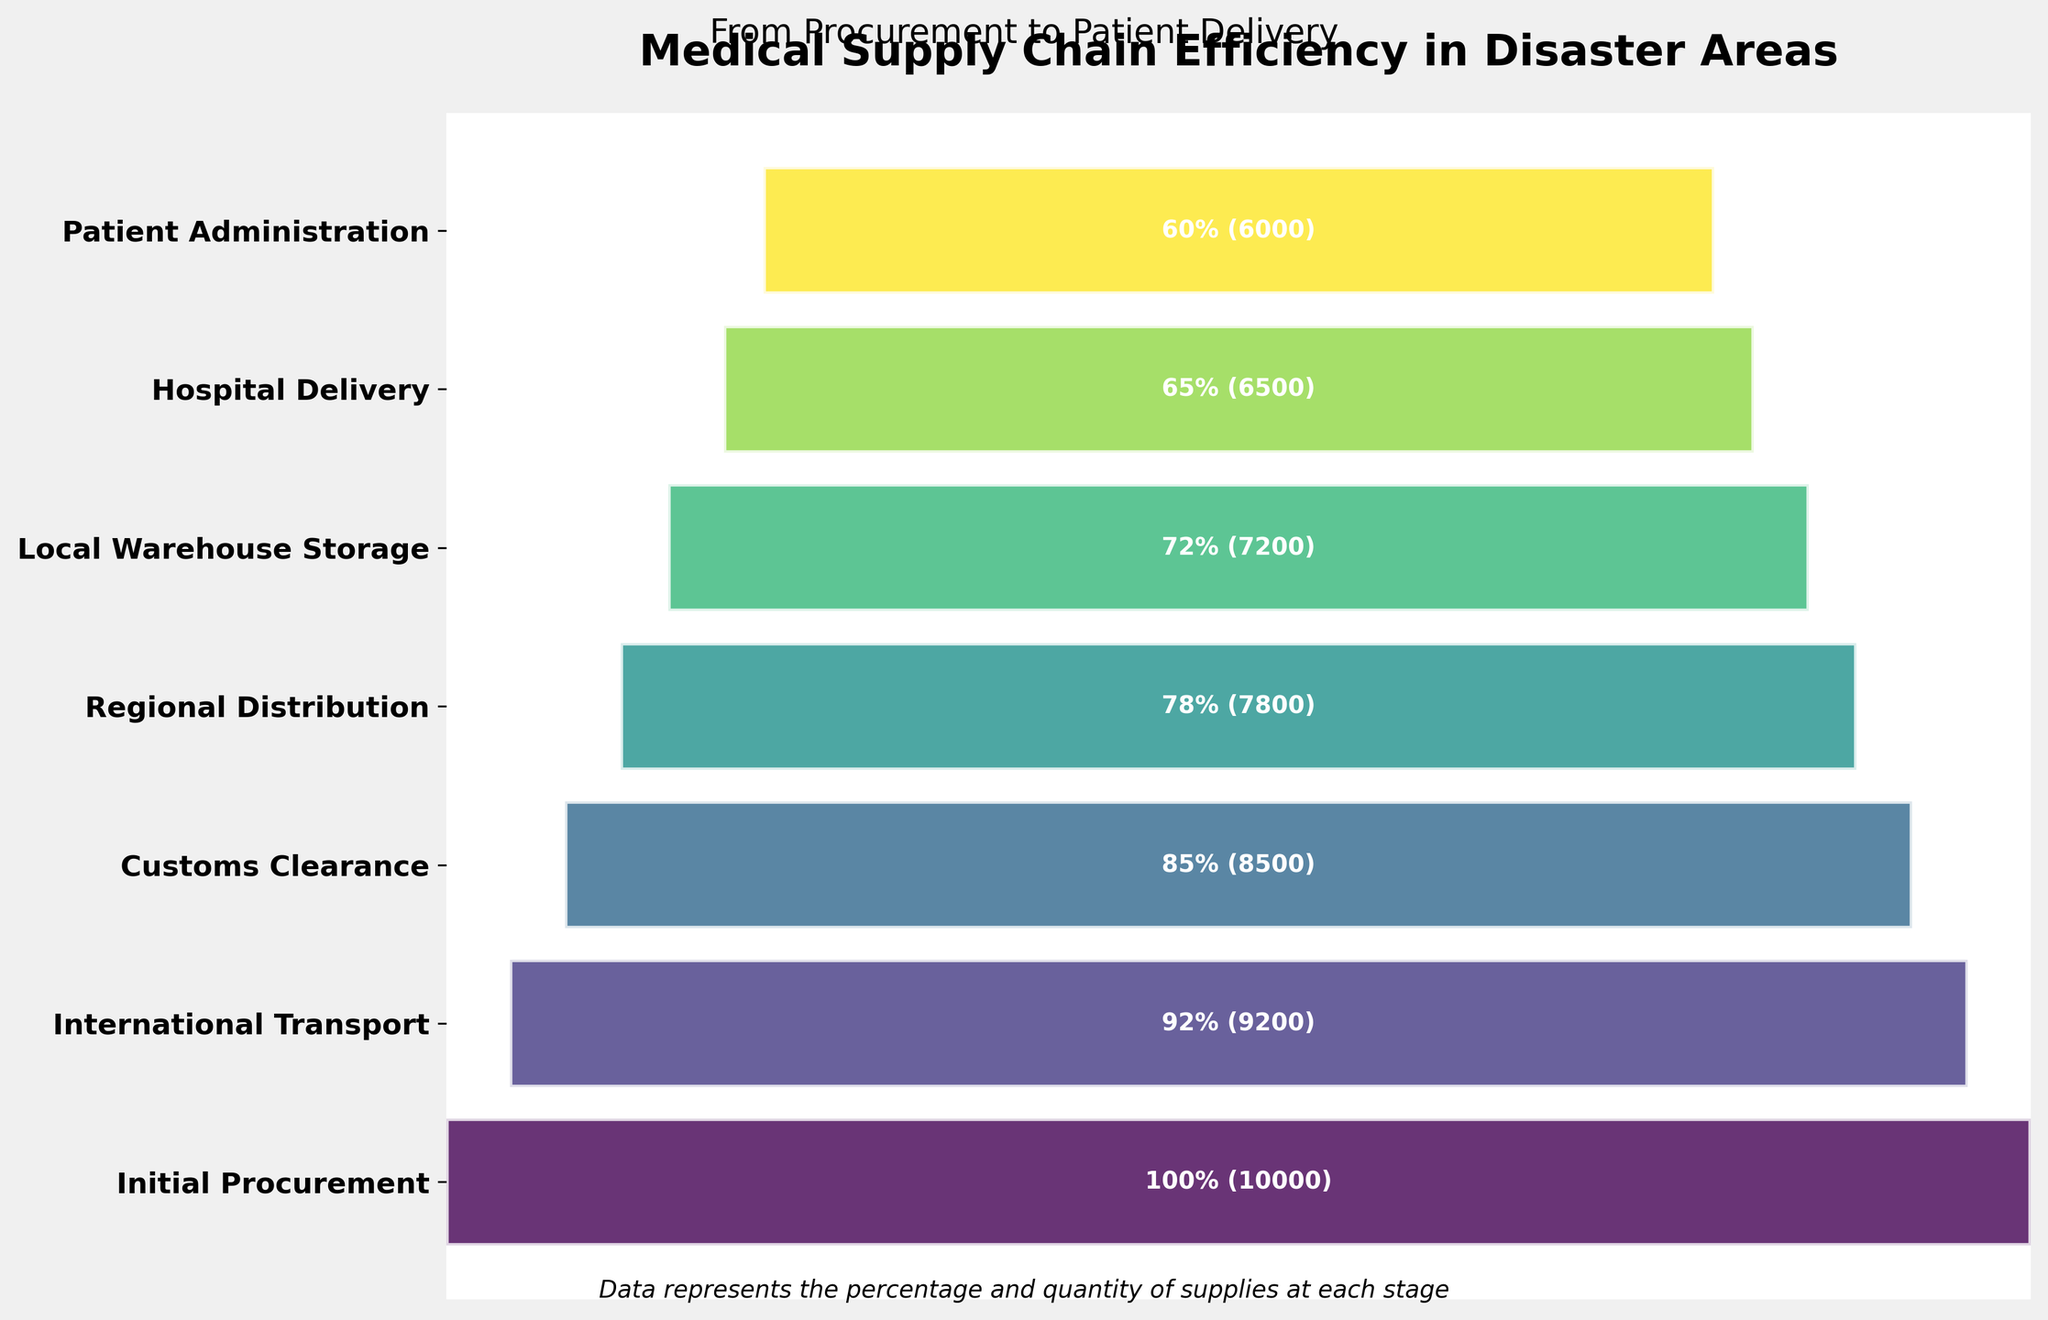What is the title of the plot? The title of the plot is the text located at the top of the figure which indicates the main topic. The title reads "Medical Supply Chain Efficiency in Disaster Areas."
Answer: Medical Supply Chain Efficiency in Disaster Areas What percentage of supplies remains after the International Transport stage? The stage labeled "International Transport" shows a percentage. By referring to this stage, we see that it shows 92%.
Answer: 92% How many supplies reach the patients? The last stage labeled "Patient Administration" shows both a percentage and the quantity. The quantity is inside the bar. There, it indicates 6000 supplies reach the patients.
Answer: 6000 What is the percentage difference between Initial Procurement and Hospital Delivery? The percentages for "Initial Procurement" and "Hospital Delivery" are 100% and 65%, respectively. To find the difference, subtract 65% from 100%, which is 35%.
Answer: 35% Which stage has the lowest percentage of supplies? By looking at all the stages and their respective percentages, the stage labeled "Patient Administration" has the lowest percentage which is 60%.
Answer: Patient Administration How many supplies are lost between Regional Distribution and Local Warehouse Storage? The quantities for "Regional Distribution" and "Local Warehouse Storage" are 7800 and 7200, respectively. Subtract 7200 from 7800 to find the loss, which equals 600 supplies.
Answer: 600 What stages experience a drop to less than 80% efficiency? The stages with percentages lower than 80% are "Regional Distribution" (78%), "Local Warehouse Storage" (72%), "Hospital Delivery" (65%), and "Patient Administration" (60%).
Answer: Regional Distribution, Local Warehouse Storage, Hospital Delivery, Patient Administration What is the average percentage of efficiencies across all stages? Sum the percentages of all stages: 100 + 92 + 85 + 78 + 72 + 65 + 60 = 552. There are 7 stages, so divide 552 by 7 to get the average, which is approximately 78.86%.
Answer: 78.86% Is the decrease in quantity from Initial Procurement to International Transport larger or smaller than the decrease from Regional Distribution to Local Warehouse Storage? From "Initial Procurement" to "International Transport" the quantity decreases from 10,000 to 9200, a loss of 800. From "Regional Distribution" to "Local Warehouse Storage," the quantity decreases from 7800 to 7200, a loss of 600. Therefore, 800 is larger than 600.
Answer: Larger What color represents the Customs Clearance stage in the funnel chart? The colors of the stages are shown in a gradient from the top to the bottom. The stage "Customs Clearance" lies in the third position from the top, showing a corresponding gradient color which is a shade of green.
Answer: Shade of green 